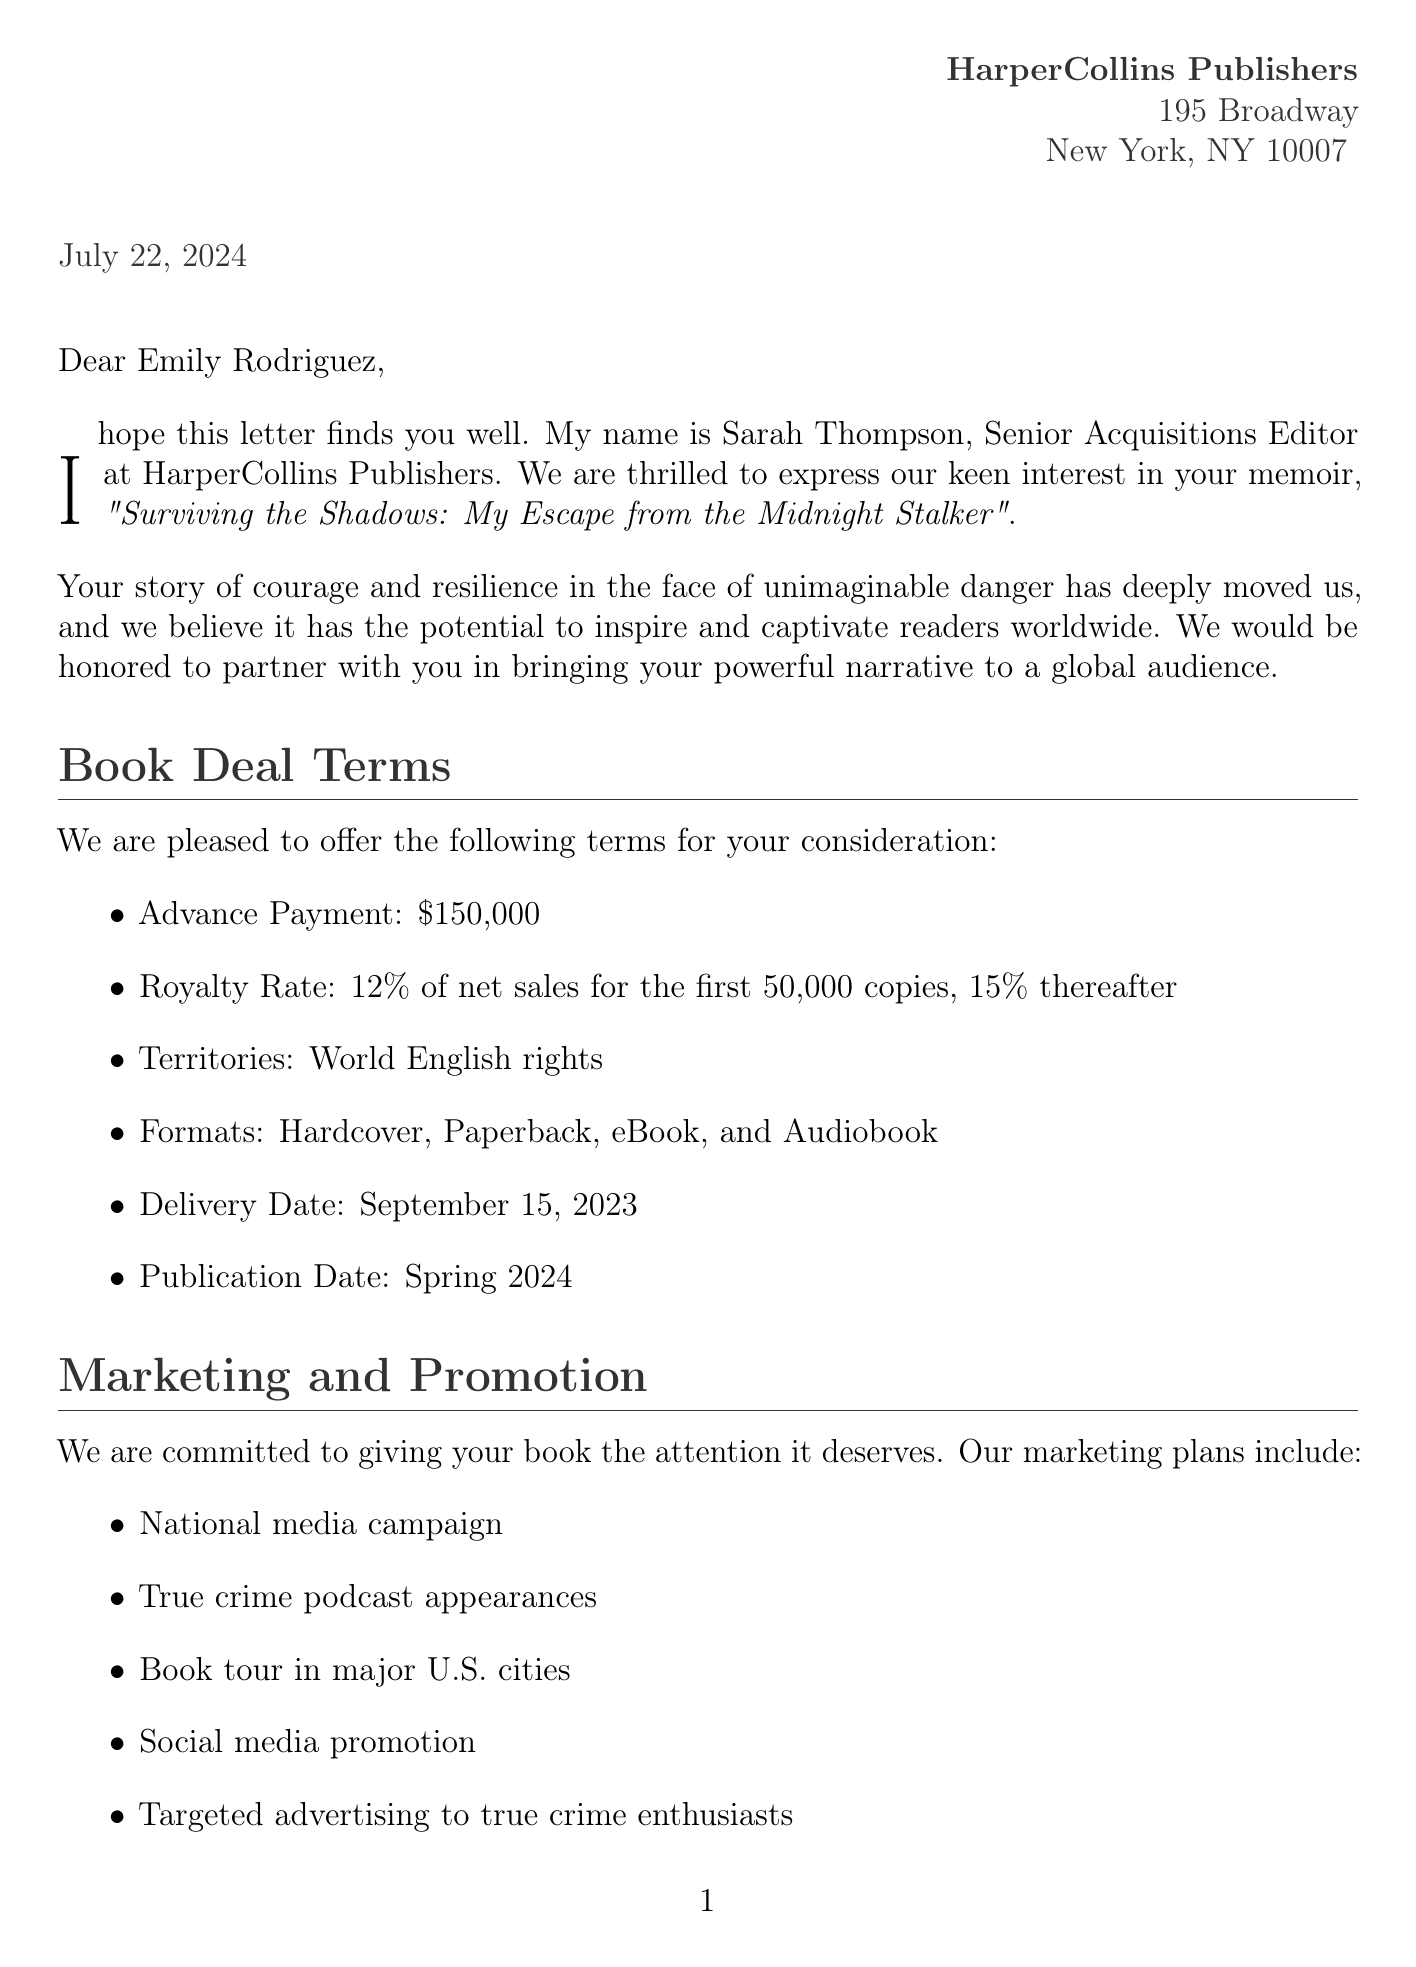What is the name of the publishing company? The name of the publishing company is mentioned in the letter.
Answer: HarperCollins Publishers What is the advance payment offered? The advance payment is one of the terms outlined in the letter.
Answer: $150,000 Who is the Senior Acquisitions Editor? The editor's name is provided in the salutation of the letter.
Answer: Sarah Thompson When is the delivery date for the manuscript? The delivery date is specified as part of the book deal terms.
Answer: September 15, 2023 What royalty rate is offered for sales after the first 50,000 copies? The royalty rate for sales beyond a certain threshold is detailed in the offer.
Answer: 15% What is the publication date of the memoir? The publication date is explicitly mentioned in the letter.
Answer: Spring 2024 What type of promotional campaign is planned? The letter outlines the marketing plans, including specific types of campaigns.
Answer: National media campaign What is the role of David Chen in the publication process? The letter states David Chen's role in supporting the author.
Answer: Senior Editor What additional opportunity is mentioned for the memoir? Additional opportunities related to the memoir are listed in the letter.
Answer: Potential for film/TV rights 